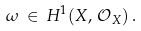Convert formula to latex. <formula><loc_0><loc_0><loc_500><loc_500>\omega \, \in \, H ^ { 1 } ( X , \, { \mathcal { O } } _ { X } ) \, .</formula> 